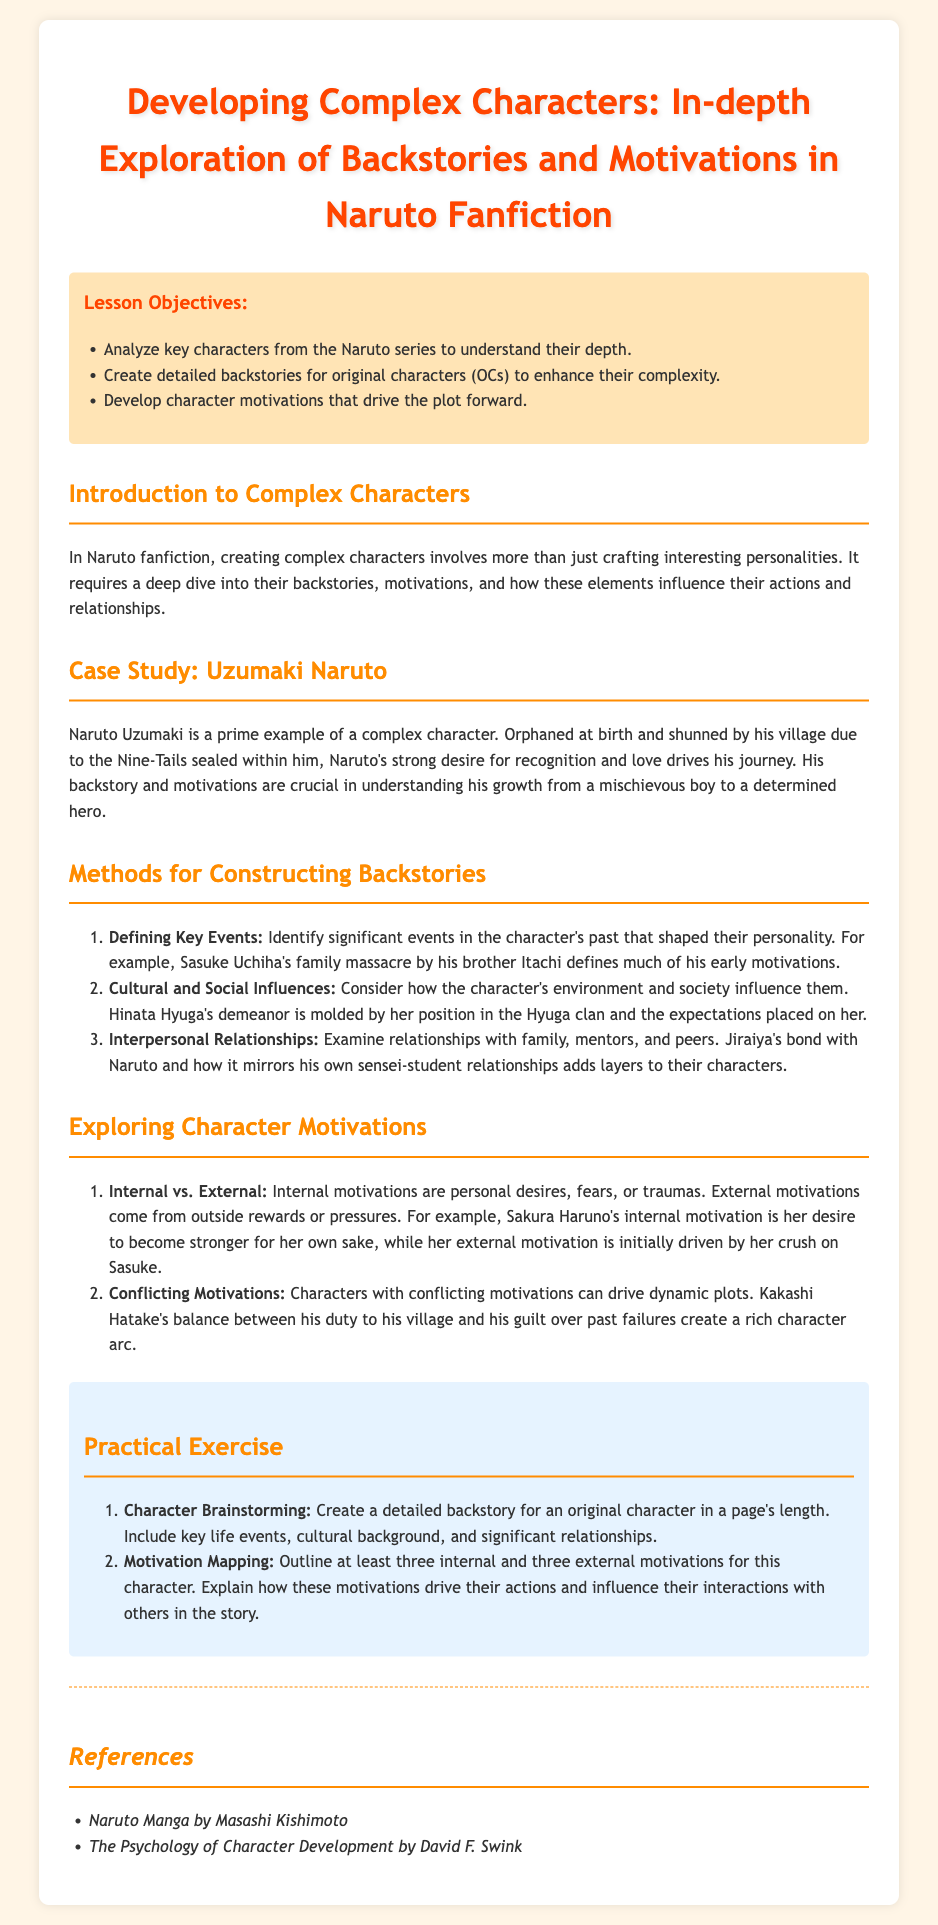what is the main title of the lesson plan? The title of the lesson plan is prominently displayed at the top of the document, indicating its focus on character development in Naruto fanfiction.
Answer: Developing Complex Characters: In-depth Exploration of Backstories and Motivations in Naruto Fanfiction how many lesson objectives are listed? The document lists a series of objectives for the lesson, which are found in the objectives section.
Answer: three who is used as a case study in the lesson plan? The case study section provides a specific character example from the Naruto series.
Answer: Uzumaki Naruto what is one method for constructing backstories mentioned in the document? The document outlines various methods for constructing backstories in the Methods for Constructing Backstories section.
Answer: Defining Key Events name one internal motivation for Sakura Haruno mentioned in the document. The document describes Sakura Haruno's motivations in the Exploring Character Motivations section.
Answer: her desire to become stronger for her own sake what type of exercise is included in the lesson plan? The practical exercise section details activities designed for learners to apply the lesson concepts.
Answer: Character Brainstorming which character’s motivations are described as conflicting? The document specifies a character who embodies conflicting motivations as part of the example in Exploring Character Motivations.
Answer: Kakashi Hatake who is the author of the Naruto manga referenced in the document? The references section cites the original creator of the Naruto series, crucial for understanding the source material.
Answer: Masashi Kishimoto 